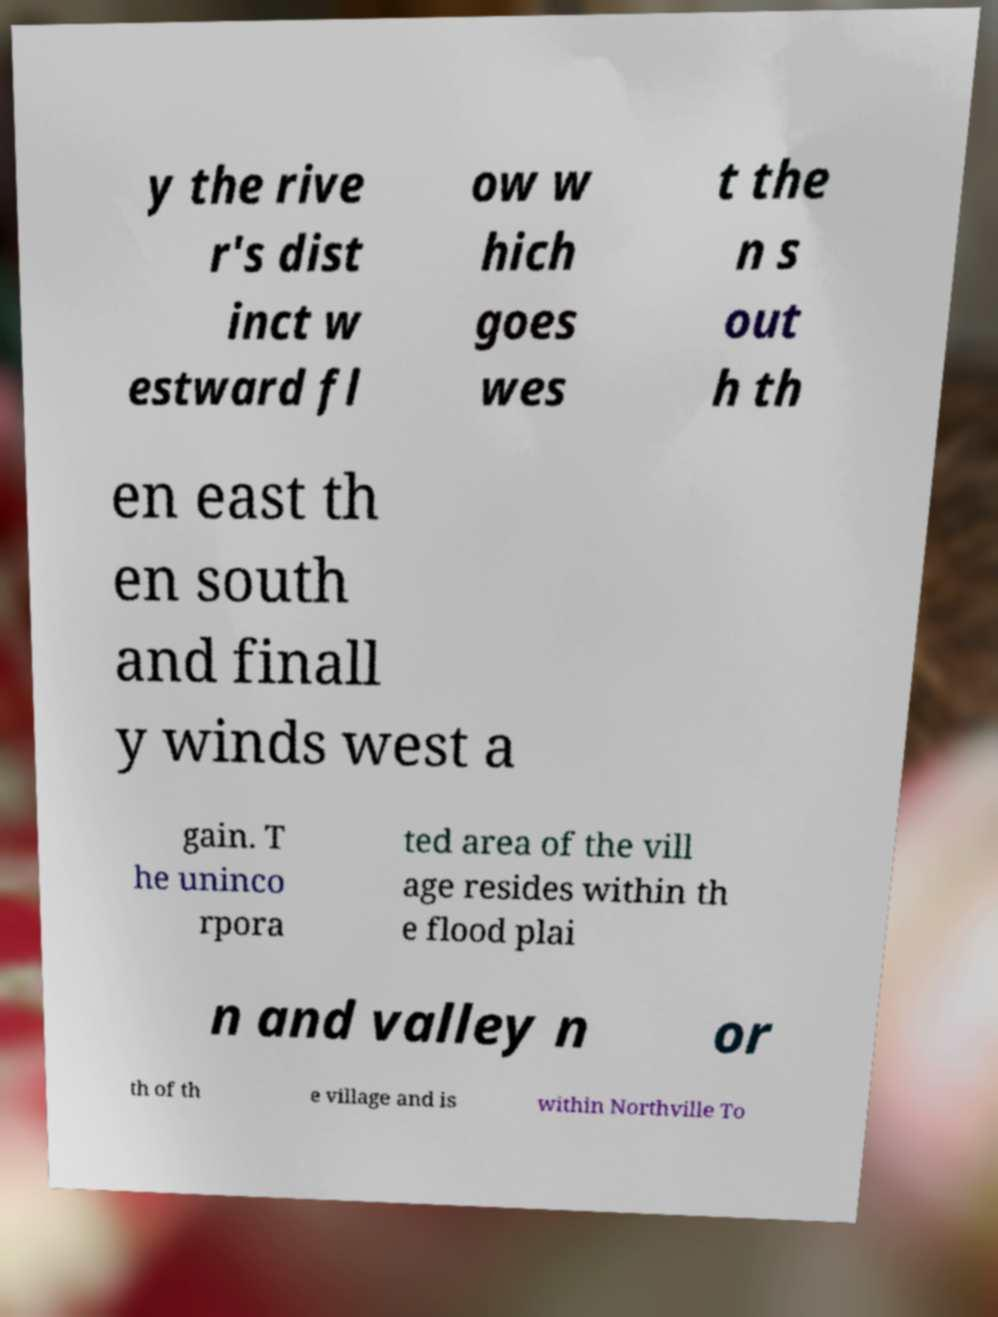Can you read and provide the text displayed in the image?This photo seems to have some interesting text. Can you extract and type it out for me? y the rive r's dist inct w estward fl ow w hich goes wes t the n s out h th en east th en south and finall y winds west a gain. T he uninco rpora ted area of the vill age resides within th e flood plai n and valley n or th of th e village and is within Northville To 